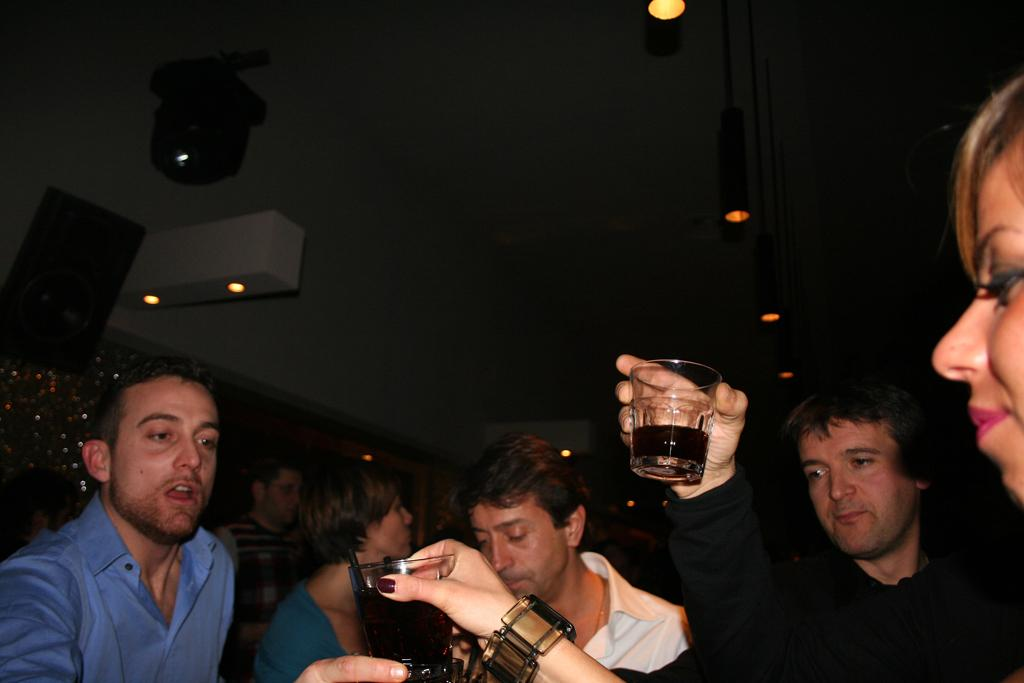How many people are present in the image? There are many people in the image. What are some people holding in the image? Some people are holding glasses containing a drink. What can be seen in the background of the image? There is a box, lights, and a wall visible in the background. What type of mine is visible in the image? There is no mine present in the image; it features a gathering of people with some holding glasses containing a drink. 